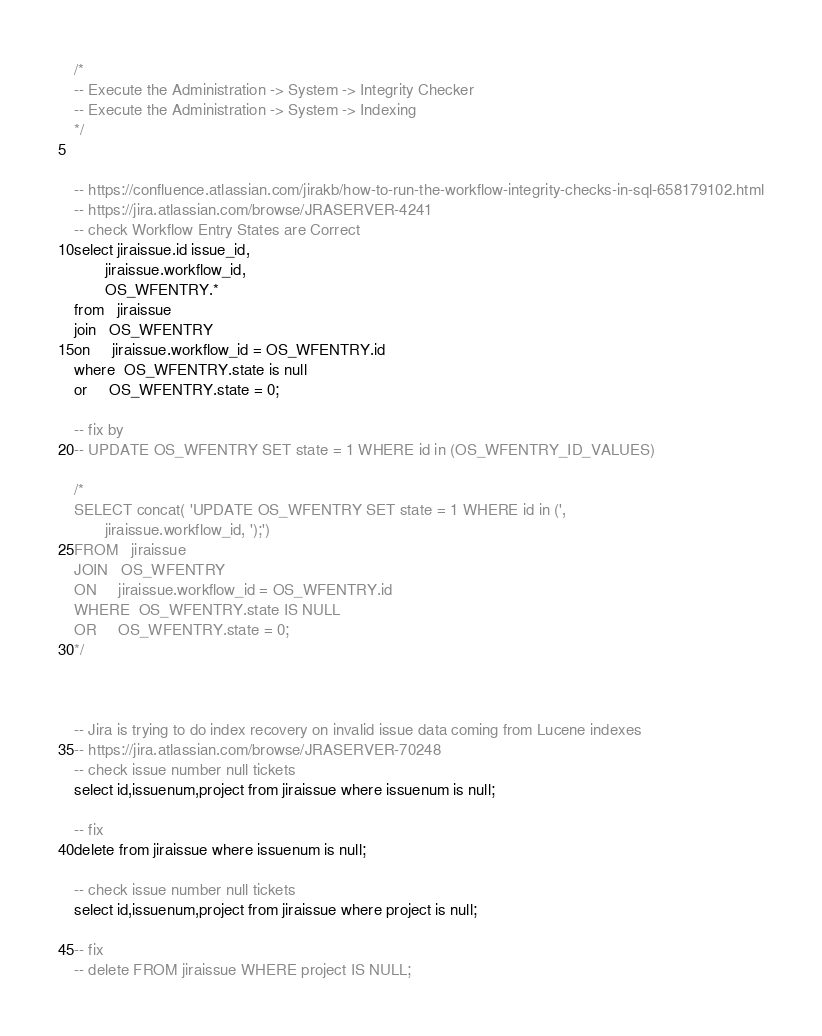<code> <loc_0><loc_0><loc_500><loc_500><_SQL_>/*
-- Execute the Administration -> System -> Integrity Checker
-- Execute the Administration -> System -> Indexing
*/


-- https://confluence.atlassian.com/jirakb/how-to-run-the-workflow-integrity-checks-in-sql-658179102.html
-- https://jira.atlassian.com/browse/JRASERVER-4241
-- check Workflow Entry States are Correct
select jiraissue.id issue_id,
       jiraissue.workflow_id,
       OS_WFENTRY.*
from   jiraissue
join   OS_WFENTRY
on     jiraissue.workflow_id = OS_WFENTRY.id
where  OS_WFENTRY.state is null
or     OS_WFENTRY.state = 0;

-- fix by
-- UPDATE OS_WFENTRY SET state = 1 WHERE id in (OS_WFENTRY_ID_VALUES)

/*
SELECT concat( 'UPDATE OS_WFENTRY SET state = 1 WHERE id in (',
       jiraissue.workflow_id, ');')
FROM   jiraissue
JOIN   OS_WFENTRY
ON     jiraissue.workflow_id = OS_WFENTRY.id
WHERE  OS_WFENTRY.state IS NULL
OR     OS_WFENTRY.state = 0;
*/



-- Jira is trying to do index recovery on invalid issue data coming from Lucene indexes
-- https://jira.atlassian.com/browse/JRASERVER-70248
-- check issue number null tickets
select id,issuenum,project from jiraissue where issuenum is null;

-- fix
delete from jiraissue where issuenum is null;

-- check issue number null tickets
select id,issuenum,project from jiraissue where project is null;

-- fix
-- delete FROM jiraissue WHERE project IS NULL;</code> 